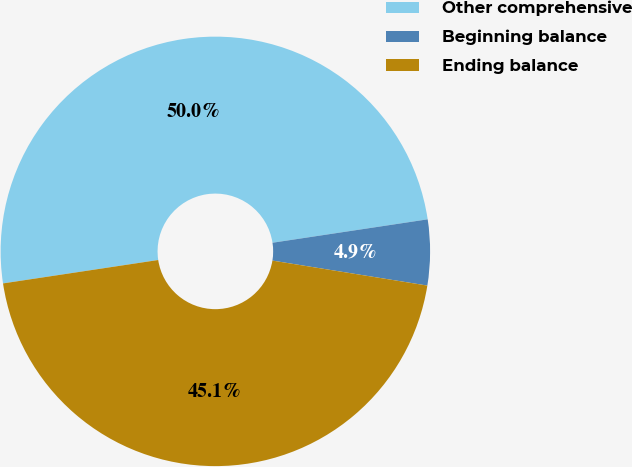<chart> <loc_0><loc_0><loc_500><loc_500><pie_chart><fcel>Other comprehensive<fcel>Beginning balance<fcel>Ending balance<nl><fcel>50.0%<fcel>4.93%<fcel>45.07%<nl></chart> 